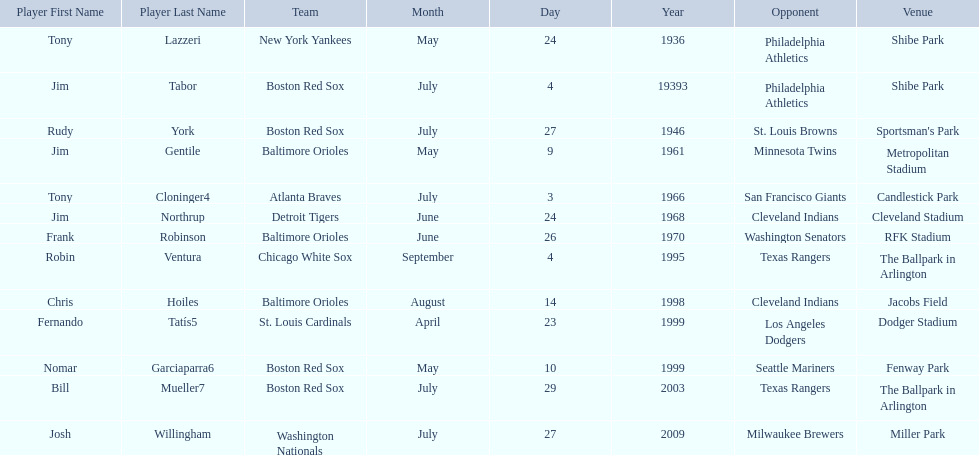Which teams played between the years 1960 and 1970? Baltimore Orioles, Atlanta Braves, Detroit Tigers, Baltimore Orioles. Of these teams that played, which ones played against the cleveland indians? Detroit Tigers. On what day did these two teams play? June 24, 1968. 